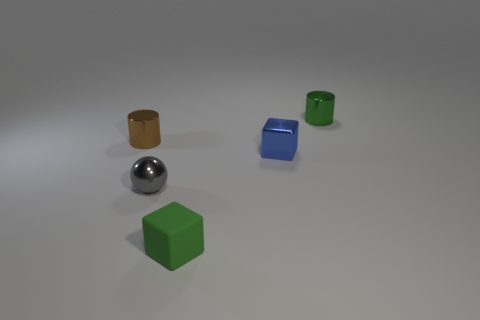Are there any cylinders that have the same color as the rubber thing?
Give a very brief answer. Yes. Are there any tiny metal cylinders behind the green cylinder?
Ensure brevity in your answer.  No. What number of objects are either small shiny objects that are right of the tiny gray shiny sphere or tiny metal objects that are to the left of the green matte block?
Offer a very short reply. 4. What number of objects are the same color as the small rubber cube?
Your answer should be very brief. 1. There is another tiny shiny thing that is the same shape as the small brown object; what is its color?
Give a very brief answer. Green. There is a small object that is on the left side of the small green metallic thing and right of the tiny green rubber block; what shape is it?
Your answer should be compact. Cube. Is the number of blue blocks greater than the number of small yellow matte cylinders?
Your response must be concise. Yes. What material is the small green cylinder?
Make the answer very short. Metal. What size is the rubber thing that is the same shape as the tiny blue metallic object?
Make the answer very short. Small. Are there any tiny blocks that are to the right of the green thing that is in front of the small green metal cylinder?
Give a very brief answer. Yes. 